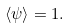Convert formula to latex. <formula><loc_0><loc_0><loc_500><loc_500>\langle \psi \rangle = 1 .</formula> 